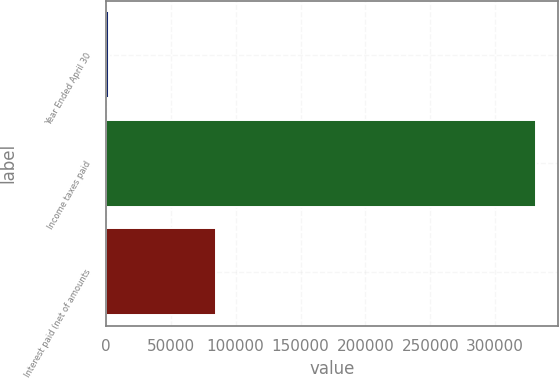Convert chart. <chart><loc_0><loc_0><loc_500><loc_500><bar_chart><fcel>Year Ended April 30<fcel>Income taxes paid<fcel>Interest paid (net of amounts<nl><fcel>2004<fcel>331635<fcel>84551<nl></chart> 